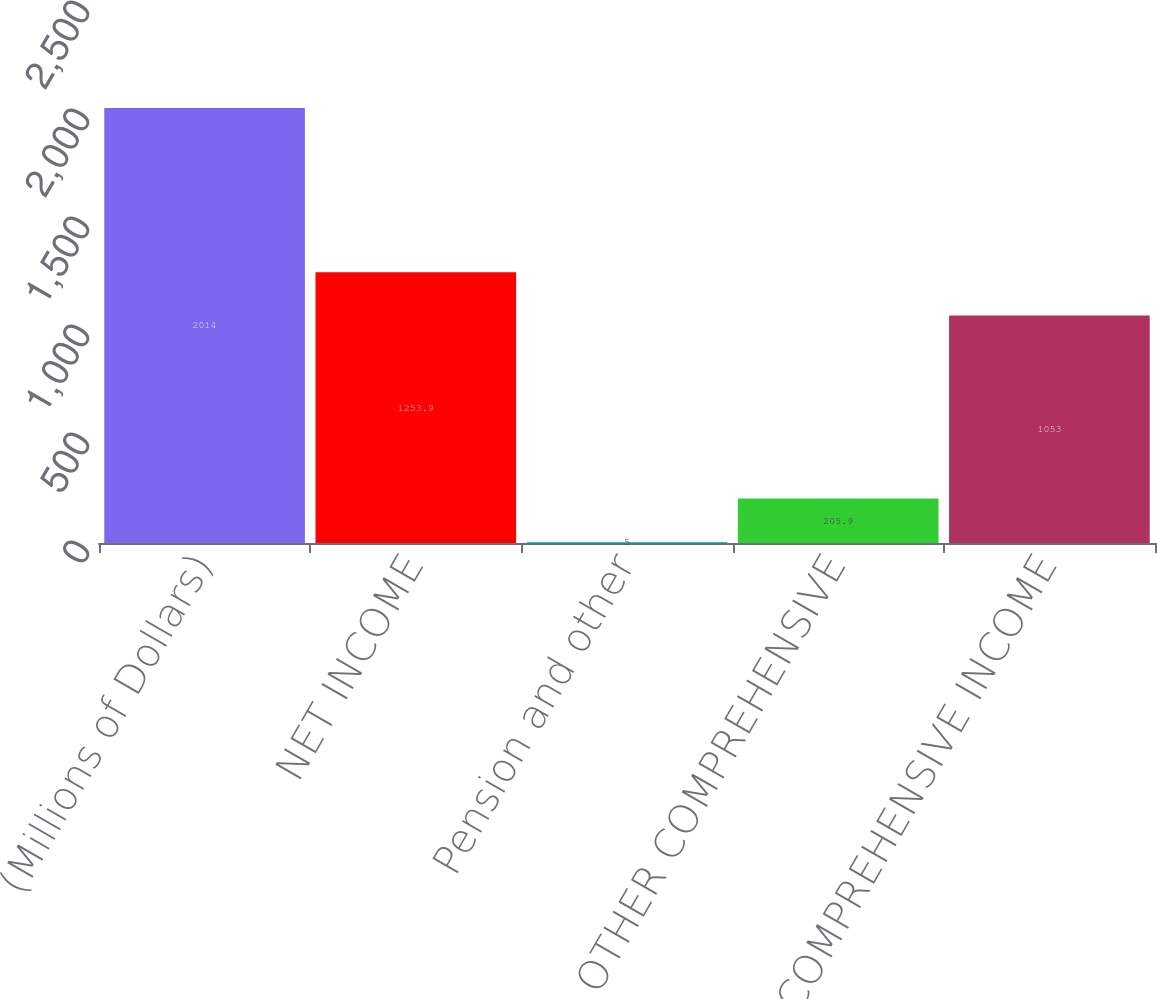Convert chart. <chart><loc_0><loc_0><loc_500><loc_500><bar_chart><fcel>(Millions of Dollars)<fcel>NET INCOME<fcel>Pension and other<fcel>TOTAL OTHER COMPREHENSIVE<fcel>COMPREHENSIVE INCOME<nl><fcel>2014<fcel>1253.9<fcel>5<fcel>205.9<fcel>1053<nl></chart> 